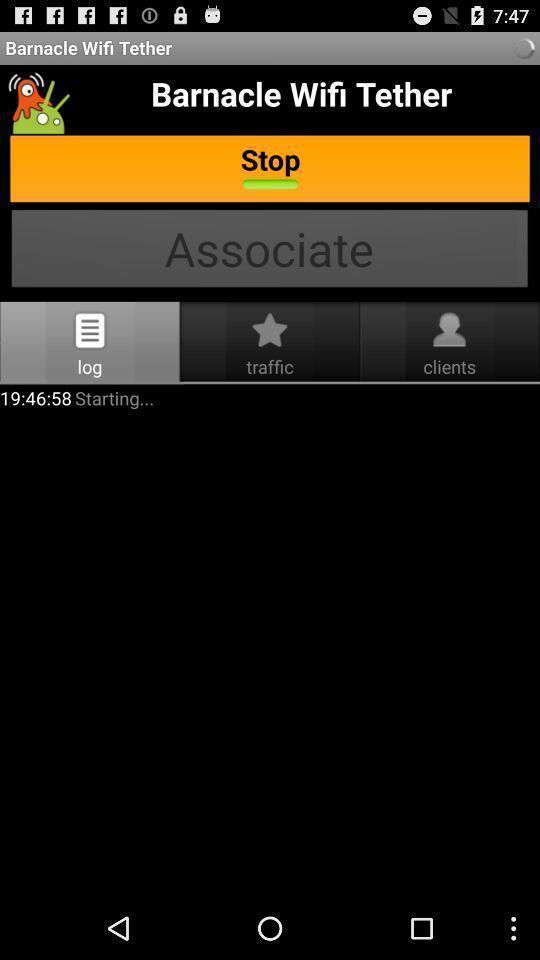Summarize the information in this screenshot. Screen showing log. 